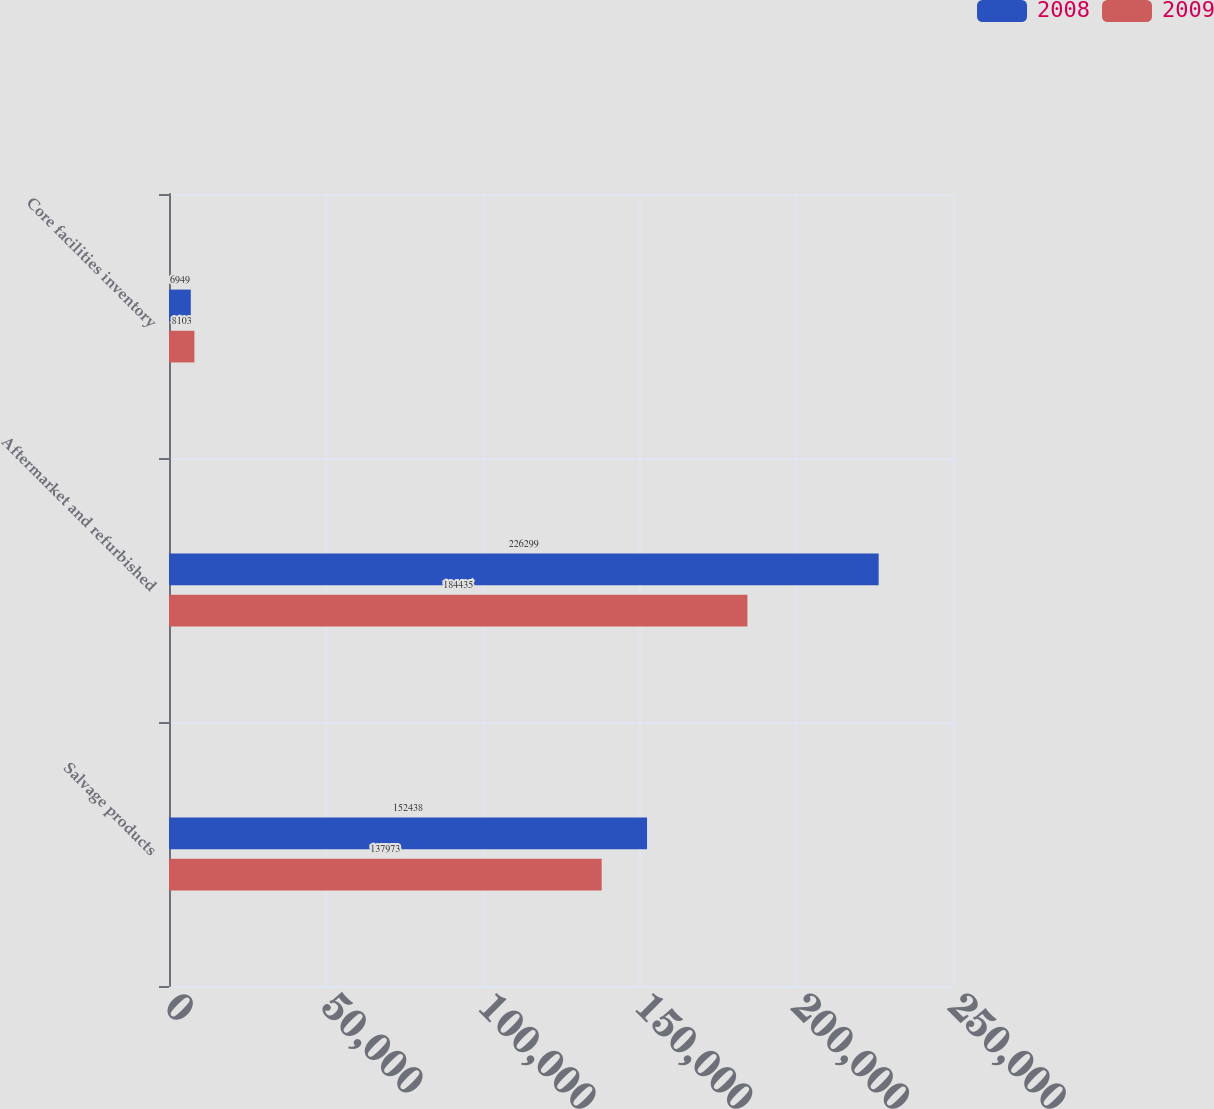<chart> <loc_0><loc_0><loc_500><loc_500><stacked_bar_chart><ecel><fcel>Salvage products<fcel>Aftermarket and refurbished<fcel>Core facilities inventory<nl><fcel>2008<fcel>152438<fcel>226299<fcel>6949<nl><fcel>2009<fcel>137973<fcel>184435<fcel>8103<nl></chart> 